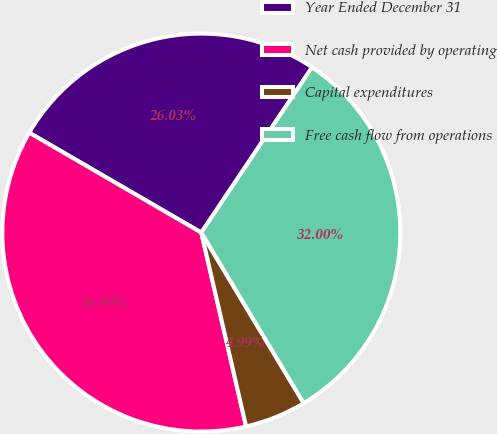Convert chart to OTSL. <chart><loc_0><loc_0><loc_500><loc_500><pie_chart><fcel>Year Ended December 31<fcel>Net cash provided by operating<fcel>Capital expenditures<fcel>Free cash flow from operations<nl><fcel>26.03%<fcel>36.99%<fcel>4.99%<fcel>32.0%<nl></chart> 